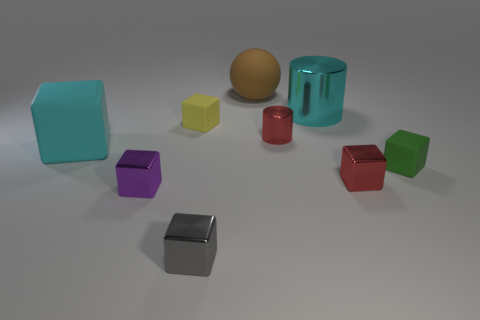There is a cyan thing in front of the large cyan metal object; what is its material?
Keep it short and to the point. Rubber. Do the cyan block and the brown rubber sphere have the same size?
Provide a short and direct response. Yes. Are there more small red metal cylinders that are left of the green rubber thing than big red matte blocks?
Make the answer very short. Yes. The gray thing that is made of the same material as the purple cube is what size?
Your response must be concise. Small. There is a yellow object; are there any things on the left side of it?
Provide a succinct answer. Yes. Is the shape of the tiny yellow thing the same as the green rubber thing?
Your answer should be compact. Yes. There is a shiny block to the right of the cyan object that is behind the tiny metallic thing behind the tiny red metallic cube; how big is it?
Ensure brevity in your answer.  Small. What is the green block made of?
Offer a very short reply. Rubber. There is a metal thing that is the same color as the tiny cylinder; what size is it?
Provide a short and direct response. Small. There is a tiny gray thing; is its shape the same as the red thing that is in front of the tiny green matte cube?
Your response must be concise. Yes. 